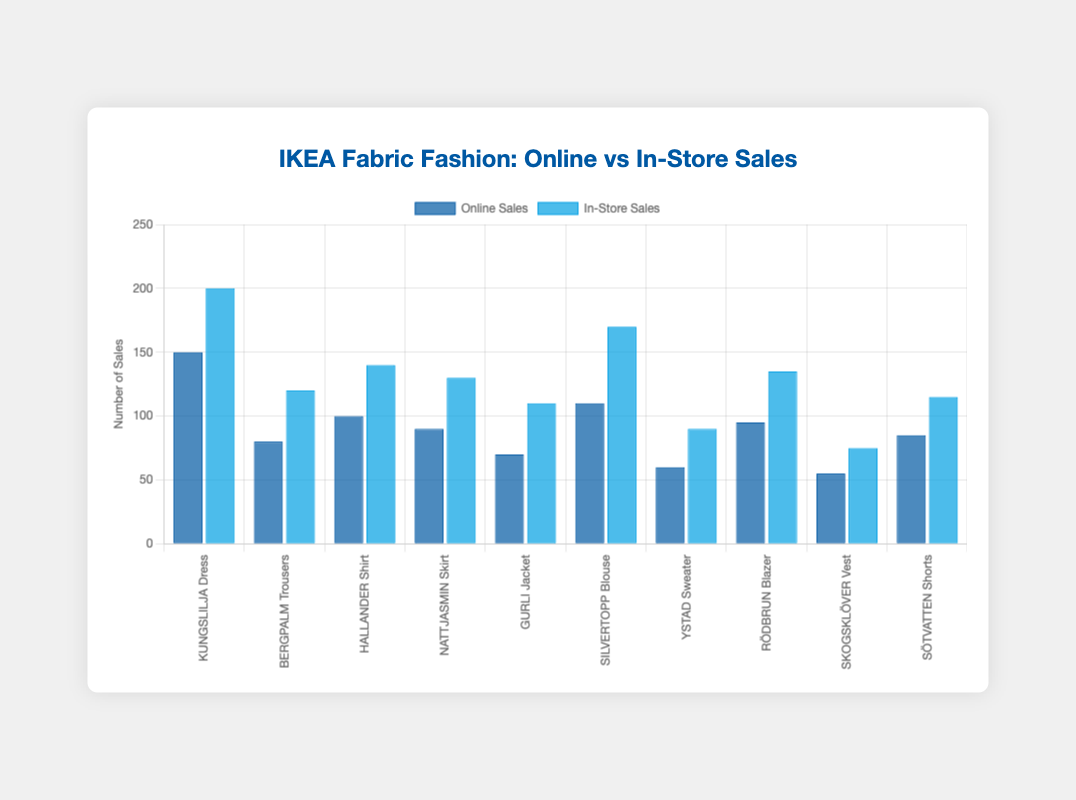Which product has the highest online sales? KUNGSLILJA Dress has the highest online sales, with 150 units. This can be determined by comparing the height of the blue bars representing online sales for each product and identifying the tallest one.
Answer: KUNGSLILJA Dress Which product shows the smallest in-store sales? SKOGSKLÖVER Vest has the smallest in-store sales, with 75 units. By examining the dark blue bars representing in-store sales, SKOGSKLÖVER Vest has the shortest bar.
Answer: SKOGSKLÖVER Vest What is the difference in online sales between KUNGSLILJA Dress and YSTAD Sweater? The online sales for KUNGSLILJA Dress are 150 units, while for YSTAD Sweater, it's 60 units. The difference is calculated as 150 - 60 = 90.
Answer: 90 Which product has a closer balance between online and in-store sales? GURLI Jacket has 70 online sales and 110 in-store sales. The difference is 110 - 70 = 40. While not identical, this difference is relatively smaller compared to other products where the differences are more significant.
Answer: GURLI Jacket Is there any product where online sales are higher than in-store sales? There is no product where online sales exceed in-store sales, which is evident by comparing all pairs of bars; the dark blue bars (in-store sales) are taller for all products.
Answer: No Which product has the largest discrepancy between online and in-store sales? SILVERTOPP Blouse has 110 online sales and 170 in-store sales, a discrepancy of 170 - 110 = 60. This difference is the largest when compared to other products.
Answer: SILVERTOPP Blouse Sum the total online sales of all products. The total online sales are 150 + 80 + 100 + 90 + 70 + 110 + 60 + 95 + 55 + 85 = 895 units.
Answer: 895 Sum the total in-store sales for all products. The total in-store sales are 200 + 120 + 140 + 130 + 110 + 170 + 90 + 135 + 75 + 115 = 1285 units.
Answer: 1285 On average, how do in-store sales compare to online sales across all products? The total online sales are 895 and in-store sales are 1285. The average online sales per product is 895/10 = 89.5, and the average in-store sales per product is 1285/10 = 128.5. On average, in-store sales exceed online sales by 128.5 - 89.5 = 39 units per product.
Answer: 39 more units Which product has the second highest online sales? HALLANDER Shirt has the second highest online sales with 100 units, after KUNGSLILJA Dress which has 150 units. This can be determined by identifying the second tallest blue bar.
Answer: HALLANDER Shirt 